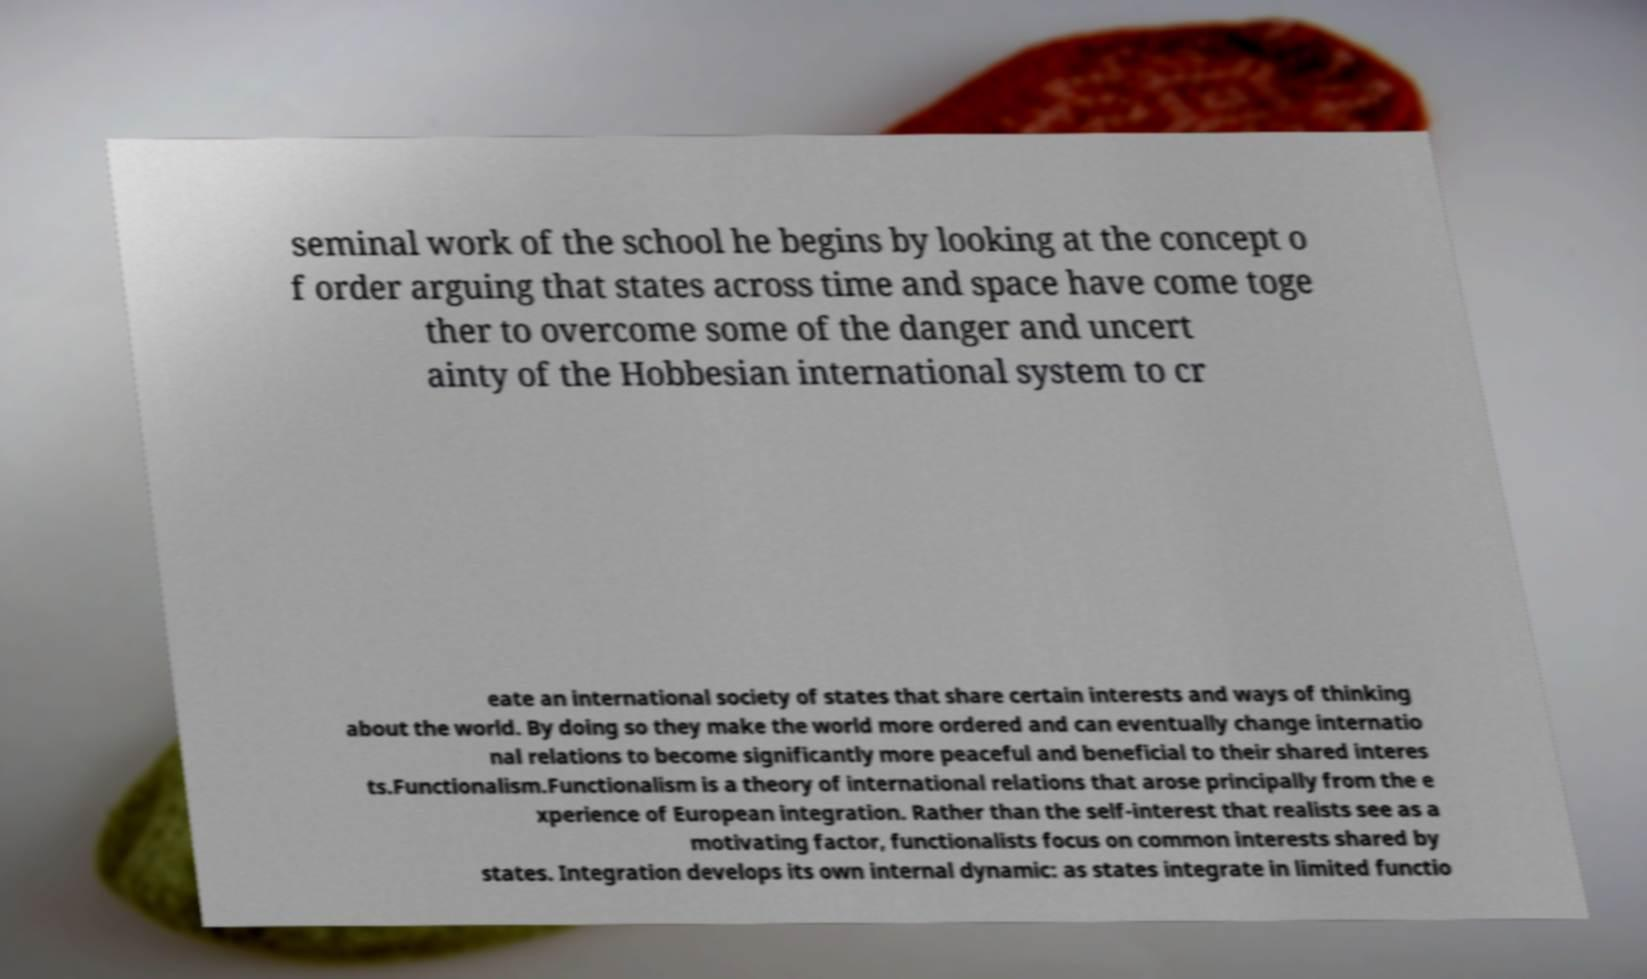Please read and relay the text visible in this image. What does it say? seminal work of the school he begins by looking at the concept o f order arguing that states across time and space have come toge ther to overcome some of the danger and uncert ainty of the Hobbesian international system to cr eate an international society of states that share certain interests and ways of thinking about the world. By doing so they make the world more ordered and can eventually change internatio nal relations to become significantly more peaceful and beneficial to their shared interes ts.Functionalism.Functionalism is a theory of international relations that arose principally from the e xperience of European integration. Rather than the self-interest that realists see as a motivating factor, functionalists focus on common interests shared by states. Integration develops its own internal dynamic: as states integrate in limited functio 